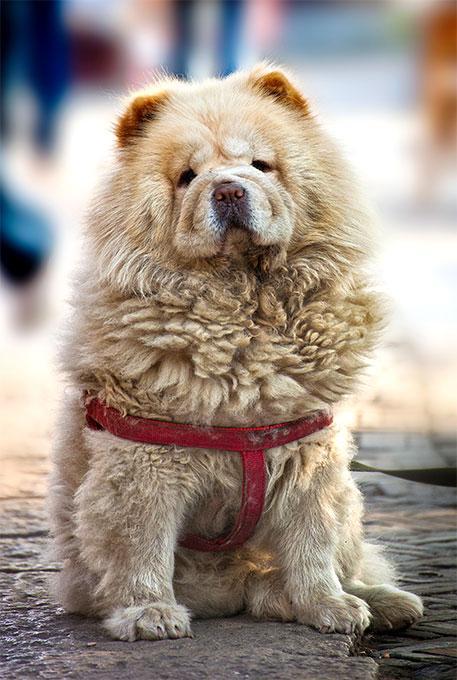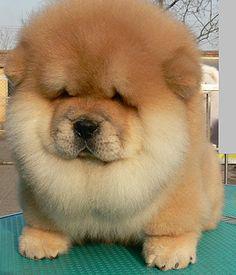The first image is the image on the left, the second image is the image on the right. Considering the images on both sides, is "One of the images shows at least two dogs." valid? Answer yes or no. No. 